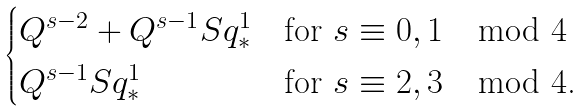<formula> <loc_0><loc_0><loc_500><loc_500>\begin{cases} Q ^ { s - 2 } + Q ^ { s - 1 } S q ^ { 1 } _ { * } & \text {for $s \equiv 0,1 \mod 4$} \\ Q ^ { s - 1 } S q ^ { 1 } _ { * } & \text {for $s \equiv 2, 3 \mod 4$.} \end{cases}</formula> 